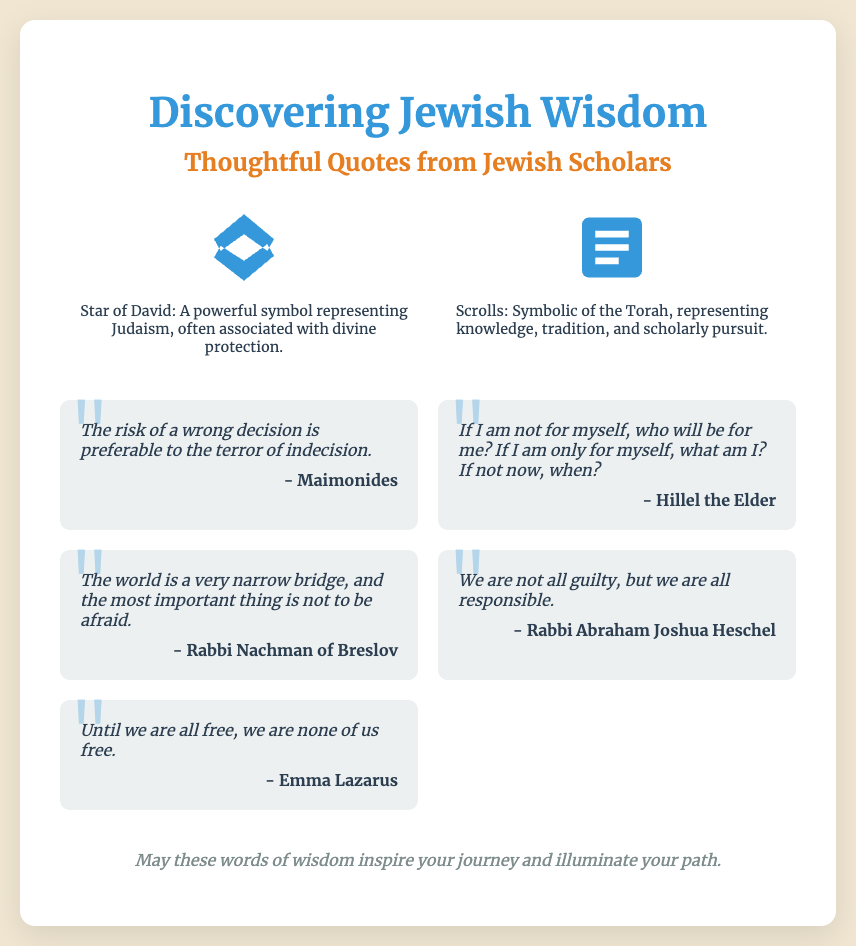What is the title of the card? The title is prominently displayed at the top of the card, indicating the central theme of the document.
Answer: Discovering Jewish Wisdom Who is the first quoted scholar? The quoted scholars are listed under their respective quotes, with Maimonides being the first.
Answer: Maimonides What two symbols are featured in the card? The symbols are explicitly described in separate sections on the card, highlighting their significance.
Answer: Star of David and Scrolls How many quotes are presented in the document? The count of quotes is based on the various quotes displayed, totaling several contributions from Jewish scholars.
Answer: Five What is the purpose of the footer message? The footer message summarizes the intention of the card, serving as an inspirational sign-off.
Answer: To inspire your journey and illuminate your path Which quote includes the phrase "If not now, when?" The analysis reveals that this specific phrase belongs to a well-known quote by the scholar Hillel the Elder.
Answer: Hillel the Elder What kind of design style does the card employ? The design style is indicated through the choice of fonts, colors, and layout used throughout the card.
Answer: Elegant and artistic What color is the background of the card? The background color is specified and creates a warm, inviting atmosphere for the content.
Answer: #f0e6d2 